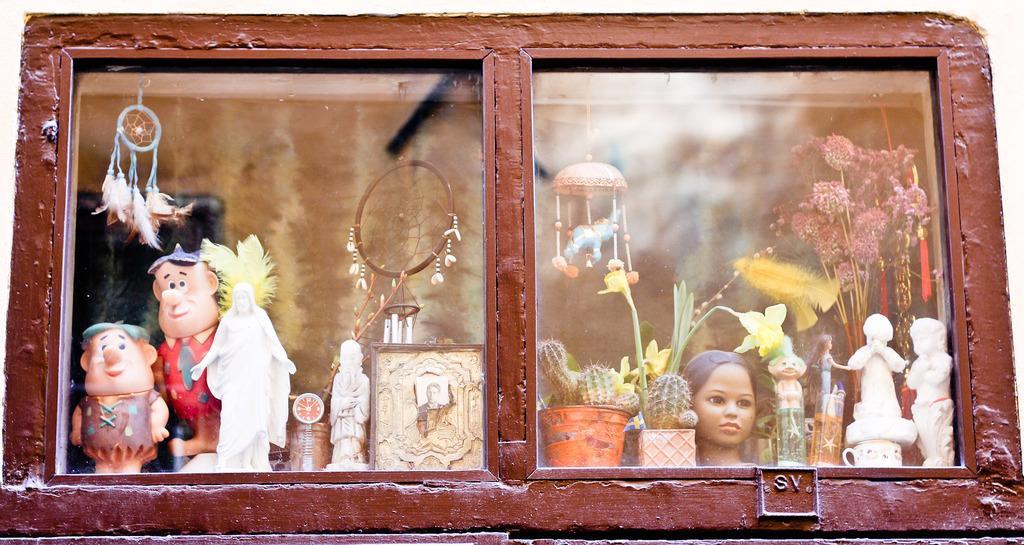What type of objects can be seen in the image? There are show pieces in the image. How are the show pieces arranged in the image? The show pieces are arranged in a wooden cupboard. What type of sidewalk can be seen in the image? There is no sidewalk present in the image; it features show pieces arranged in a wooden cupboard. How does the toe interact with the show pieces in the image? There is no toe present in the image, as it only features show pieces arranged in a wooden cupboard. 